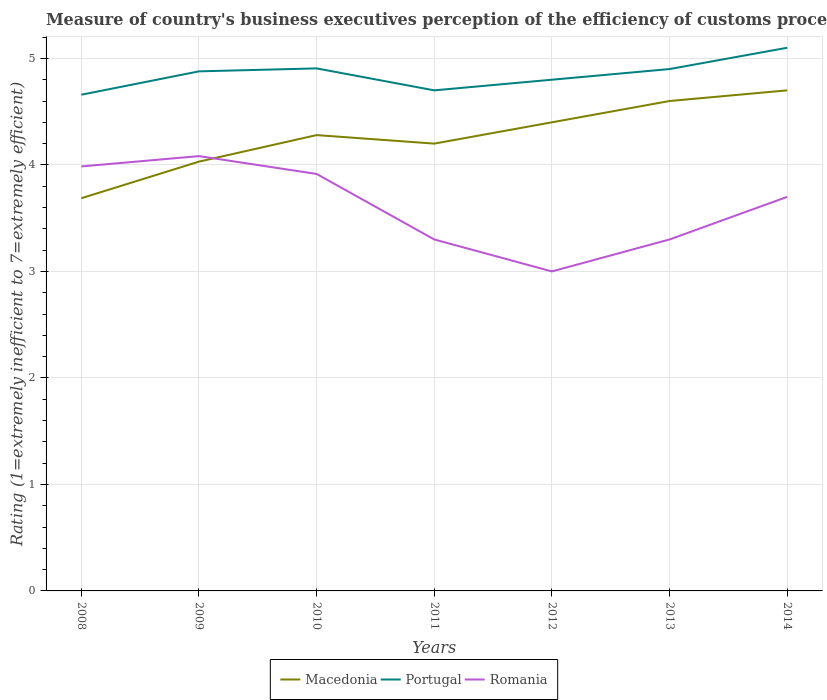Does the line corresponding to Romania intersect with the line corresponding to Portugal?
Provide a succinct answer. No. Across all years, what is the maximum rating of the efficiency of customs procedure in Romania?
Make the answer very short. 3. In which year was the rating of the efficiency of customs procedure in Portugal maximum?
Provide a succinct answer. 2008. What is the total rating of the efficiency of customs procedure in Macedonia in the graph?
Offer a very short reply. -0.4. What is the difference between the highest and the second highest rating of the efficiency of customs procedure in Portugal?
Keep it short and to the point. 0.44. What is the difference between the highest and the lowest rating of the efficiency of customs procedure in Macedonia?
Keep it short and to the point. 4. Is the rating of the efficiency of customs procedure in Romania strictly greater than the rating of the efficiency of customs procedure in Macedonia over the years?
Give a very brief answer. No. How many years are there in the graph?
Make the answer very short. 7. What is the difference between two consecutive major ticks on the Y-axis?
Make the answer very short. 1. Does the graph contain grids?
Your response must be concise. Yes. Where does the legend appear in the graph?
Provide a short and direct response. Bottom center. How many legend labels are there?
Provide a succinct answer. 3. How are the legend labels stacked?
Offer a very short reply. Horizontal. What is the title of the graph?
Offer a very short reply. Measure of country's business executives perception of the efficiency of customs procedures. What is the label or title of the X-axis?
Your response must be concise. Years. What is the label or title of the Y-axis?
Your answer should be very brief. Rating (1=extremely inefficient to 7=extremely efficient). What is the Rating (1=extremely inefficient to 7=extremely efficient) of Macedonia in 2008?
Your answer should be very brief. 3.69. What is the Rating (1=extremely inefficient to 7=extremely efficient) of Portugal in 2008?
Ensure brevity in your answer.  4.66. What is the Rating (1=extremely inefficient to 7=extremely efficient) in Romania in 2008?
Provide a short and direct response. 3.99. What is the Rating (1=extremely inefficient to 7=extremely efficient) of Macedonia in 2009?
Provide a short and direct response. 4.03. What is the Rating (1=extremely inefficient to 7=extremely efficient) in Portugal in 2009?
Offer a very short reply. 4.88. What is the Rating (1=extremely inefficient to 7=extremely efficient) in Romania in 2009?
Offer a terse response. 4.08. What is the Rating (1=extremely inefficient to 7=extremely efficient) of Macedonia in 2010?
Offer a terse response. 4.28. What is the Rating (1=extremely inefficient to 7=extremely efficient) in Portugal in 2010?
Give a very brief answer. 4.91. What is the Rating (1=extremely inefficient to 7=extremely efficient) of Romania in 2010?
Your response must be concise. 3.92. What is the Rating (1=extremely inefficient to 7=extremely efficient) in Macedonia in 2011?
Offer a terse response. 4.2. What is the Rating (1=extremely inefficient to 7=extremely efficient) of Portugal in 2011?
Provide a short and direct response. 4.7. What is the Rating (1=extremely inefficient to 7=extremely efficient) in Romania in 2011?
Offer a very short reply. 3.3. What is the Rating (1=extremely inefficient to 7=extremely efficient) of Macedonia in 2012?
Your response must be concise. 4.4. What is the Rating (1=extremely inefficient to 7=extremely efficient) in Portugal in 2012?
Make the answer very short. 4.8. What is the Rating (1=extremely inefficient to 7=extremely efficient) in Macedonia in 2013?
Provide a succinct answer. 4.6. What is the Rating (1=extremely inefficient to 7=extremely efficient) of Romania in 2013?
Provide a short and direct response. 3.3. What is the Rating (1=extremely inefficient to 7=extremely efficient) of Macedonia in 2014?
Give a very brief answer. 4.7. What is the Rating (1=extremely inefficient to 7=extremely efficient) of Romania in 2014?
Your answer should be compact. 3.7. Across all years, what is the maximum Rating (1=extremely inefficient to 7=extremely efficient) of Romania?
Give a very brief answer. 4.08. Across all years, what is the minimum Rating (1=extremely inefficient to 7=extremely efficient) of Macedonia?
Give a very brief answer. 3.69. Across all years, what is the minimum Rating (1=extremely inefficient to 7=extremely efficient) in Portugal?
Ensure brevity in your answer.  4.66. Across all years, what is the minimum Rating (1=extremely inefficient to 7=extremely efficient) of Romania?
Ensure brevity in your answer.  3. What is the total Rating (1=extremely inefficient to 7=extremely efficient) in Macedonia in the graph?
Your answer should be very brief. 29.9. What is the total Rating (1=extremely inefficient to 7=extremely efficient) in Portugal in the graph?
Your answer should be compact. 33.94. What is the total Rating (1=extremely inefficient to 7=extremely efficient) of Romania in the graph?
Give a very brief answer. 25.28. What is the difference between the Rating (1=extremely inefficient to 7=extremely efficient) in Macedonia in 2008 and that in 2009?
Your answer should be compact. -0.34. What is the difference between the Rating (1=extremely inefficient to 7=extremely efficient) of Portugal in 2008 and that in 2009?
Offer a terse response. -0.22. What is the difference between the Rating (1=extremely inefficient to 7=extremely efficient) in Romania in 2008 and that in 2009?
Ensure brevity in your answer.  -0.1. What is the difference between the Rating (1=extremely inefficient to 7=extremely efficient) of Macedonia in 2008 and that in 2010?
Your response must be concise. -0.59. What is the difference between the Rating (1=extremely inefficient to 7=extremely efficient) in Portugal in 2008 and that in 2010?
Give a very brief answer. -0.25. What is the difference between the Rating (1=extremely inefficient to 7=extremely efficient) of Romania in 2008 and that in 2010?
Provide a short and direct response. 0.07. What is the difference between the Rating (1=extremely inefficient to 7=extremely efficient) of Macedonia in 2008 and that in 2011?
Keep it short and to the point. -0.51. What is the difference between the Rating (1=extremely inefficient to 7=extremely efficient) in Portugal in 2008 and that in 2011?
Ensure brevity in your answer.  -0.04. What is the difference between the Rating (1=extremely inefficient to 7=extremely efficient) of Romania in 2008 and that in 2011?
Ensure brevity in your answer.  0.69. What is the difference between the Rating (1=extremely inefficient to 7=extremely efficient) in Macedonia in 2008 and that in 2012?
Ensure brevity in your answer.  -0.71. What is the difference between the Rating (1=extremely inefficient to 7=extremely efficient) of Portugal in 2008 and that in 2012?
Offer a terse response. -0.14. What is the difference between the Rating (1=extremely inefficient to 7=extremely efficient) in Romania in 2008 and that in 2012?
Offer a very short reply. 0.99. What is the difference between the Rating (1=extremely inefficient to 7=extremely efficient) of Macedonia in 2008 and that in 2013?
Your answer should be compact. -0.91. What is the difference between the Rating (1=extremely inefficient to 7=extremely efficient) of Portugal in 2008 and that in 2013?
Your response must be concise. -0.24. What is the difference between the Rating (1=extremely inefficient to 7=extremely efficient) of Romania in 2008 and that in 2013?
Keep it short and to the point. 0.69. What is the difference between the Rating (1=extremely inefficient to 7=extremely efficient) of Macedonia in 2008 and that in 2014?
Keep it short and to the point. -1.01. What is the difference between the Rating (1=extremely inefficient to 7=extremely efficient) in Portugal in 2008 and that in 2014?
Offer a very short reply. -0.44. What is the difference between the Rating (1=extremely inefficient to 7=extremely efficient) of Romania in 2008 and that in 2014?
Provide a short and direct response. 0.29. What is the difference between the Rating (1=extremely inefficient to 7=extremely efficient) in Macedonia in 2009 and that in 2010?
Offer a terse response. -0.25. What is the difference between the Rating (1=extremely inefficient to 7=extremely efficient) in Portugal in 2009 and that in 2010?
Make the answer very short. -0.03. What is the difference between the Rating (1=extremely inefficient to 7=extremely efficient) of Romania in 2009 and that in 2010?
Your answer should be very brief. 0.17. What is the difference between the Rating (1=extremely inefficient to 7=extremely efficient) in Macedonia in 2009 and that in 2011?
Your answer should be very brief. -0.17. What is the difference between the Rating (1=extremely inefficient to 7=extremely efficient) of Portugal in 2009 and that in 2011?
Provide a short and direct response. 0.18. What is the difference between the Rating (1=extremely inefficient to 7=extremely efficient) of Romania in 2009 and that in 2011?
Your answer should be very brief. 0.78. What is the difference between the Rating (1=extremely inefficient to 7=extremely efficient) in Macedonia in 2009 and that in 2012?
Make the answer very short. -0.37. What is the difference between the Rating (1=extremely inefficient to 7=extremely efficient) in Portugal in 2009 and that in 2012?
Ensure brevity in your answer.  0.08. What is the difference between the Rating (1=extremely inefficient to 7=extremely efficient) in Romania in 2009 and that in 2012?
Make the answer very short. 1.08. What is the difference between the Rating (1=extremely inefficient to 7=extremely efficient) in Macedonia in 2009 and that in 2013?
Offer a very short reply. -0.57. What is the difference between the Rating (1=extremely inefficient to 7=extremely efficient) in Portugal in 2009 and that in 2013?
Make the answer very short. -0.02. What is the difference between the Rating (1=extremely inefficient to 7=extremely efficient) of Romania in 2009 and that in 2013?
Your answer should be compact. 0.78. What is the difference between the Rating (1=extremely inefficient to 7=extremely efficient) in Macedonia in 2009 and that in 2014?
Give a very brief answer. -0.67. What is the difference between the Rating (1=extremely inefficient to 7=extremely efficient) in Portugal in 2009 and that in 2014?
Keep it short and to the point. -0.22. What is the difference between the Rating (1=extremely inefficient to 7=extremely efficient) of Romania in 2009 and that in 2014?
Your answer should be very brief. 0.38. What is the difference between the Rating (1=extremely inefficient to 7=extremely efficient) in Portugal in 2010 and that in 2011?
Provide a short and direct response. 0.21. What is the difference between the Rating (1=extremely inefficient to 7=extremely efficient) in Romania in 2010 and that in 2011?
Provide a succinct answer. 0.62. What is the difference between the Rating (1=extremely inefficient to 7=extremely efficient) in Macedonia in 2010 and that in 2012?
Your answer should be very brief. -0.12. What is the difference between the Rating (1=extremely inefficient to 7=extremely efficient) in Portugal in 2010 and that in 2012?
Your answer should be compact. 0.11. What is the difference between the Rating (1=extremely inefficient to 7=extremely efficient) of Romania in 2010 and that in 2012?
Give a very brief answer. 0.92. What is the difference between the Rating (1=extremely inefficient to 7=extremely efficient) of Macedonia in 2010 and that in 2013?
Provide a succinct answer. -0.32. What is the difference between the Rating (1=extremely inefficient to 7=extremely efficient) in Portugal in 2010 and that in 2013?
Make the answer very short. 0.01. What is the difference between the Rating (1=extremely inefficient to 7=extremely efficient) in Romania in 2010 and that in 2013?
Your answer should be very brief. 0.62. What is the difference between the Rating (1=extremely inefficient to 7=extremely efficient) of Macedonia in 2010 and that in 2014?
Give a very brief answer. -0.42. What is the difference between the Rating (1=extremely inefficient to 7=extremely efficient) of Portugal in 2010 and that in 2014?
Offer a very short reply. -0.19. What is the difference between the Rating (1=extremely inefficient to 7=extremely efficient) in Romania in 2010 and that in 2014?
Your answer should be very brief. 0.22. What is the difference between the Rating (1=extremely inefficient to 7=extremely efficient) of Macedonia in 2011 and that in 2012?
Your response must be concise. -0.2. What is the difference between the Rating (1=extremely inefficient to 7=extremely efficient) of Portugal in 2011 and that in 2012?
Your answer should be very brief. -0.1. What is the difference between the Rating (1=extremely inefficient to 7=extremely efficient) of Romania in 2011 and that in 2012?
Offer a very short reply. 0.3. What is the difference between the Rating (1=extremely inefficient to 7=extremely efficient) of Macedonia in 2011 and that in 2013?
Offer a very short reply. -0.4. What is the difference between the Rating (1=extremely inefficient to 7=extremely efficient) in Portugal in 2011 and that in 2014?
Provide a succinct answer. -0.4. What is the difference between the Rating (1=extremely inefficient to 7=extremely efficient) of Romania in 2011 and that in 2014?
Ensure brevity in your answer.  -0.4. What is the difference between the Rating (1=extremely inefficient to 7=extremely efficient) in Portugal in 2012 and that in 2013?
Provide a succinct answer. -0.1. What is the difference between the Rating (1=extremely inefficient to 7=extremely efficient) of Portugal in 2012 and that in 2014?
Offer a terse response. -0.3. What is the difference between the Rating (1=extremely inefficient to 7=extremely efficient) in Romania in 2012 and that in 2014?
Offer a very short reply. -0.7. What is the difference between the Rating (1=extremely inefficient to 7=extremely efficient) of Portugal in 2013 and that in 2014?
Give a very brief answer. -0.2. What is the difference between the Rating (1=extremely inefficient to 7=extremely efficient) in Macedonia in 2008 and the Rating (1=extremely inefficient to 7=extremely efficient) in Portugal in 2009?
Ensure brevity in your answer.  -1.19. What is the difference between the Rating (1=extremely inefficient to 7=extremely efficient) of Macedonia in 2008 and the Rating (1=extremely inefficient to 7=extremely efficient) of Romania in 2009?
Provide a succinct answer. -0.4. What is the difference between the Rating (1=extremely inefficient to 7=extremely efficient) in Portugal in 2008 and the Rating (1=extremely inefficient to 7=extremely efficient) in Romania in 2009?
Give a very brief answer. 0.58. What is the difference between the Rating (1=extremely inefficient to 7=extremely efficient) of Macedonia in 2008 and the Rating (1=extremely inefficient to 7=extremely efficient) of Portugal in 2010?
Provide a succinct answer. -1.22. What is the difference between the Rating (1=extremely inefficient to 7=extremely efficient) of Macedonia in 2008 and the Rating (1=extremely inefficient to 7=extremely efficient) of Romania in 2010?
Your answer should be compact. -0.23. What is the difference between the Rating (1=extremely inefficient to 7=extremely efficient) in Portugal in 2008 and the Rating (1=extremely inefficient to 7=extremely efficient) in Romania in 2010?
Ensure brevity in your answer.  0.74. What is the difference between the Rating (1=extremely inefficient to 7=extremely efficient) of Macedonia in 2008 and the Rating (1=extremely inefficient to 7=extremely efficient) of Portugal in 2011?
Make the answer very short. -1.01. What is the difference between the Rating (1=extremely inefficient to 7=extremely efficient) in Macedonia in 2008 and the Rating (1=extremely inefficient to 7=extremely efficient) in Romania in 2011?
Provide a short and direct response. 0.39. What is the difference between the Rating (1=extremely inefficient to 7=extremely efficient) of Portugal in 2008 and the Rating (1=extremely inefficient to 7=extremely efficient) of Romania in 2011?
Make the answer very short. 1.36. What is the difference between the Rating (1=extremely inefficient to 7=extremely efficient) in Macedonia in 2008 and the Rating (1=extremely inefficient to 7=extremely efficient) in Portugal in 2012?
Ensure brevity in your answer.  -1.11. What is the difference between the Rating (1=extremely inefficient to 7=extremely efficient) in Macedonia in 2008 and the Rating (1=extremely inefficient to 7=extremely efficient) in Romania in 2012?
Your answer should be very brief. 0.69. What is the difference between the Rating (1=extremely inefficient to 7=extremely efficient) of Portugal in 2008 and the Rating (1=extremely inefficient to 7=extremely efficient) of Romania in 2012?
Your answer should be very brief. 1.66. What is the difference between the Rating (1=extremely inefficient to 7=extremely efficient) of Macedonia in 2008 and the Rating (1=extremely inefficient to 7=extremely efficient) of Portugal in 2013?
Offer a very short reply. -1.21. What is the difference between the Rating (1=extremely inefficient to 7=extremely efficient) in Macedonia in 2008 and the Rating (1=extremely inefficient to 7=extremely efficient) in Romania in 2013?
Provide a succinct answer. 0.39. What is the difference between the Rating (1=extremely inefficient to 7=extremely efficient) in Portugal in 2008 and the Rating (1=extremely inefficient to 7=extremely efficient) in Romania in 2013?
Make the answer very short. 1.36. What is the difference between the Rating (1=extremely inefficient to 7=extremely efficient) of Macedonia in 2008 and the Rating (1=extremely inefficient to 7=extremely efficient) of Portugal in 2014?
Give a very brief answer. -1.41. What is the difference between the Rating (1=extremely inefficient to 7=extremely efficient) of Macedonia in 2008 and the Rating (1=extremely inefficient to 7=extremely efficient) of Romania in 2014?
Provide a short and direct response. -0.01. What is the difference between the Rating (1=extremely inefficient to 7=extremely efficient) in Macedonia in 2009 and the Rating (1=extremely inefficient to 7=extremely efficient) in Portugal in 2010?
Your response must be concise. -0.88. What is the difference between the Rating (1=extremely inefficient to 7=extremely efficient) of Macedonia in 2009 and the Rating (1=extremely inefficient to 7=extremely efficient) of Romania in 2010?
Your answer should be very brief. 0.12. What is the difference between the Rating (1=extremely inefficient to 7=extremely efficient) in Portugal in 2009 and the Rating (1=extremely inefficient to 7=extremely efficient) in Romania in 2010?
Your answer should be very brief. 0.96. What is the difference between the Rating (1=extremely inefficient to 7=extremely efficient) in Macedonia in 2009 and the Rating (1=extremely inefficient to 7=extremely efficient) in Portugal in 2011?
Your answer should be compact. -0.67. What is the difference between the Rating (1=extremely inefficient to 7=extremely efficient) of Macedonia in 2009 and the Rating (1=extremely inefficient to 7=extremely efficient) of Romania in 2011?
Offer a terse response. 0.73. What is the difference between the Rating (1=extremely inefficient to 7=extremely efficient) of Portugal in 2009 and the Rating (1=extremely inefficient to 7=extremely efficient) of Romania in 2011?
Offer a terse response. 1.58. What is the difference between the Rating (1=extremely inefficient to 7=extremely efficient) of Macedonia in 2009 and the Rating (1=extremely inefficient to 7=extremely efficient) of Portugal in 2012?
Offer a very short reply. -0.77. What is the difference between the Rating (1=extremely inefficient to 7=extremely efficient) in Macedonia in 2009 and the Rating (1=extremely inefficient to 7=extremely efficient) in Romania in 2012?
Provide a short and direct response. 1.03. What is the difference between the Rating (1=extremely inefficient to 7=extremely efficient) in Portugal in 2009 and the Rating (1=extremely inefficient to 7=extremely efficient) in Romania in 2012?
Provide a short and direct response. 1.88. What is the difference between the Rating (1=extremely inefficient to 7=extremely efficient) of Macedonia in 2009 and the Rating (1=extremely inefficient to 7=extremely efficient) of Portugal in 2013?
Your answer should be compact. -0.87. What is the difference between the Rating (1=extremely inefficient to 7=extremely efficient) of Macedonia in 2009 and the Rating (1=extremely inefficient to 7=extremely efficient) of Romania in 2013?
Your answer should be very brief. 0.73. What is the difference between the Rating (1=extremely inefficient to 7=extremely efficient) in Portugal in 2009 and the Rating (1=extremely inefficient to 7=extremely efficient) in Romania in 2013?
Give a very brief answer. 1.58. What is the difference between the Rating (1=extremely inefficient to 7=extremely efficient) of Macedonia in 2009 and the Rating (1=extremely inefficient to 7=extremely efficient) of Portugal in 2014?
Ensure brevity in your answer.  -1.07. What is the difference between the Rating (1=extremely inefficient to 7=extremely efficient) of Macedonia in 2009 and the Rating (1=extremely inefficient to 7=extremely efficient) of Romania in 2014?
Give a very brief answer. 0.33. What is the difference between the Rating (1=extremely inefficient to 7=extremely efficient) of Portugal in 2009 and the Rating (1=extremely inefficient to 7=extremely efficient) of Romania in 2014?
Ensure brevity in your answer.  1.18. What is the difference between the Rating (1=extremely inefficient to 7=extremely efficient) of Macedonia in 2010 and the Rating (1=extremely inefficient to 7=extremely efficient) of Portugal in 2011?
Provide a succinct answer. -0.42. What is the difference between the Rating (1=extremely inefficient to 7=extremely efficient) of Portugal in 2010 and the Rating (1=extremely inefficient to 7=extremely efficient) of Romania in 2011?
Provide a short and direct response. 1.61. What is the difference between the Rating (1=extremely inefficient to 7=extremely efficient) of Macedonia in 2010 and the Rating (1=extremely inefficient to 7=extremely efficient) of Portugal in 2012?
Offer a very short reply. -0.52. What is the difference between the Rating (1=extremely inefficient to 7=extremely efficient) in Macedonia in 2010 and the Rating (1=extremely inefficient to 7=extremely efficient) in Romania in 2012?
Keep it short and to the point. 1.28. What is the difference between the Rating (1=extremely inefficient to 7=extremely efficient) of Portugal in 2010 and the Rating (1=extremely inefficient to 7=extremely efficient) of Romania in 2012?
Give a very brief answer. 1.91. What is the difference between the Rating (1=extremely inefficient to 7=extremely efficient) in Macedonia in 2010 and the Rating (1=extremely inefficient to 7=extremely efficient) in Portugal in 2013?
Make the answer very short. -0.62. What is the difference between the Rating (1=extremely inefficient to 7=extremely efficient) of Portugal in 2010 and the Rating (1=extremely inefficient to 7=extremely efficient) of Romania in 2013?
Your answer should be very brief. 1.61. What is the difference between the Rating (1=extremely inefficient to 7=extremely efficient) in Macedonia in 2010 and the Rating (1=extremely inefficient to 7=extremely efficient) in Portugal in 2014?
Provide a succinct answer. -0.82. What is the difference between the Rating (1=extremely inefficient to 7=extremely efficient) of Macedonia in 2010 and the Rating (1=extremely inefficient to 7=extremely efficient) of Romania in 2014?
Your response must be concise. 0.58. What is the difference between the Rating (1=extremely inefficient to 7=extremely efficient) of Portugal in 2010 and the Rating (1=extremely inefficient to 7=extremely efficient) of Romania in 2014?
Ensure brevity in your answer.  1.21. What is the difference between the Rating (1=extremely inefficient to 7=extremely efficient) in Macedonia in 2012 and the Rating (1=extremely inefficient to 7=extremely efficient) in Portugal in 2013?
Provide a short and direct response. -0.5. What is the difference between the Rating (1=extremely inefficient to 7=extremely efficient) of Macedonia in 2012 and the Rating (1=extremely inefficient to 7=extremely efficient) of Romania in 2013?
Your answer should be compact. 1.1. What is the difference between the Rating (1=extremely inefficient to 7=extremely efficient) in Portugal in 2012 and the Rating (1=extremely inefficient to 7=extremely efficient) in Romania in 2013?
Your answer should be compact. 1.5. What is the difference between the Rating (1=extremely inefficient to 7=extremely efficient) of Macedonia in 2012 and the Rating (1=extremely inefficient to 7=extremely efficient) of Portugal in 2014?
Your answer should be very brief. -0.7. What is the difference between the Rating (1=extremely inefficient to 7=extremely efficient) in Portugal in 2013 and the Rating (1=extremely inefficient to 7=extremely efficient) in Romania in 2014?
Make the answer very short. 1.2. What is the average Rating (1=extremely inefficient to 7=extremely efficient) in Macedonia per year?
Your answer should be compact. 4.27. What is the average Rating (1=extremely inefficient to 7=extremely efficient) of Portugal per year?
Your response must be concise. 4.85. What is the average Rating (1=extremely inefficient to 7=extremely efficient) in Romania per year?
Your answer should be compact. 3.61. In the year 2008, what is the difference between the Rating (1=extremely inefficient to 7=extremely efficient) in Macedonia and Rating (1=extremely inefficient to 7=extremely efficient) in Portugal?
Provide a short and direct response. -0.97. In the year 2008, what is the difference between the Rating (1=extremely inefficient to 7=extremely efficient) in Macedonia and Rating (1=extremely inefficient to 7=extremely efficient) in Romania?
Keep it short and to the point. -0.3. In the year 2008, what is the difference between the Rating (1=extremely inefficient to 7=extremely efficient) of Portugal and Rating (1=extremely inefficient to 7=extremely efficient) of Romania?
Keep it short and to the point. 0.67. In the year 2009, what is the difference between the Rating (1=extremely inefficient to 7=extremely efficient) of Macedonia and Rating (1=extremely inefficient to 7=extremely efficient) of Portugal?
Your answer should be very brief. -0.85. In the year 2009, what is the difference between the Rating (1=extremely inefficient to 7=extremely efficient) in Macedonia and Rating (1=extremely inefficient to 7=extremely efficient) in Romania?
Give a very brief answer. -0.05. In the year 2009, what is the difference between the Rating (1=extremely inefficient to 7=extremely efficient) in Portugal and Rating (1=extremely inefficient to 7=extremely efficient) in Romania?
Your answer should be compact. 0.8. In the year 2010, what is the difference between the Rating (1=extremely inefficient to 7=extremely efficient) of Macedonia and Rating (1=extremely inefficient to 7=extremely efficient) of Portugal?
Keep it short and to the point. -0.63. In the year 2010, what is the difference between the Rating (1=extremely inefficient to 7=extremely efficient) of Macedonia and Rating (1=extremely inefficient to 7=extremely efficient) of Romania?
Offer a terse response. 0.36. In the year 2011, what is the difference between the Rating (1=extremely inefficient to 7=extremely efficient) in Macedonia and Rating (1=extremely inefficient to 7=extremely efficient) in Portugal?
Make the answer very short. -0.5. In the year 2011, what is the difference between the Rating (1=extremely inefficient to 7=extremely efficient) in Macedonia and Rating (1=extremely inefficient to 7=extremely efficient) in Romania?
Ensure brevity in your answer.  0.9. In the year 2011, what is the difference between the Rating (1=extremely inefficient to 7=extremely efficient) in Portugal and Rating (1=extremely inefficient to 7=extremely efficient) in Romania?
Keep it short and to the point. 1.4. In the year 2012, what is the difference between the Rating (1=extremely inefficient to 7=extremely efficient) in Macedonia and Rating (1=extremely inefficient to 7=extremely efficient) in Portugal?
Offer a terse response. -0.4. In the year 2012, what is the difference between the Rating (1=extremely inefficient to 7=extremely efficient) of Portugal and Rating (1=extremely inefficient to 7=extremely efficient) of Romania?
Your answer should be very brief. 1.8. In the year 2013, what is the difference between the Rating (1=extremely inefficient to 7=extremely efficient) of Macedonia and Rating (1=extremely inefficient to 7=extremely efficient) of Portugal?
Provide a succinct answer. -0.3. In the year 2014, what is the difference between the Rating (1=extremely inefficient to 7=extremely efficient) in Macedonia and Rating (1=extremely inefficient to 7=extremely efficient) in Portugal?
Provide a succinct answer. -0.4. In the year 2014, what is the difference between the Rating (1=extremely inefficient to 7=extremely efficient) of Macedonia and Rating (1=extremely inefficient to 7=extremely efficient) of Romania?
Give a very brief answer. 1. What is the ratio of the Rating (1=extremely inefficient to 7=extremely efficient) of Macedonia in 2008 to that in 2009?
Keep it short and to the point. 0.91. What is the ratio of the Rating (1=extremely inefficient to 7=extremely efficient) in Portugal in 2008 to that in 2009?
Offer a terse response. 0.95. What is the ratio of the Rating (1=extremely inefficient to 7=extremely efficient) in Romania in 2008 to that in 2009?
Your response must be concise. 0.98. What is the ratio of the Rating (1=extremely inefficient to 7=extremely efficient) in Macedonia in 2008 to that in 2010?
Provide a short and direct response. 0.86. What is the ratio of the Rating (1=extremely inefficient to 7=extremely efficient) in Portugal in 2008 to that in 2010?
Your answer should be very brief. 0.95. What is the ratio of the Rating (1=extremely inefficient to 7=extremely efficient) in Macedonia in 2008 to that in 2011?
Make the answer very short. 0.88. What is the ratio of the Rating (1=extremely inefficient to 7=extremely efficient) of Portugal in 2008 to that in 2011?
Offer a terse response. 0.99. What is the ratio of the Rating (1=extremely inefficient to 7=extremely efficient) in Romania in 2008 to that in 2011?
Provide a succinct answer. 1.21. What is the ratio of the Rating (1=extremely inefficient to 7=extremely efficient) in Macedonia in 2008 to that in 2012?
Your response must be concise. 0.84. What is the ratio of the Rating (1=extremely inefficient to 7=extremely efficient) of Portugal in 2008 to that in 2012?
Provide a short and direct response. 0.97. What is the ratio of the Rating (1=extremely inefficient to 7=extremely efficient) in Romania in 2008 to that in 2012?
Your answer should be compact. 1.33. What is the ratio of the Rating (1=extremely inefficient to 7=extremely efficient) in Macedonia in 2008 to that in 2013?
Keep it short and to the point. 0.8. What is the ratio of the Rating (1=extremely inefficient to 7=extremely efficient) in Portugal in 2008 to that in 2013?
Make the answer very short. 0.95. What is the ratio of the Rating (1=extremely inefficient to 7=extremely efficient) in Romania in 2008 to that in 2013?
Offer a very short reply. 1.21. What is the ratio of the Rating (1=extremely inefficient to 7=extremely efficient) of Macedonia in 2008 to that in 2014?
Your response must be concise. 0.78. What is the ratio of the Rating (1=extremely inefficient to 7=extremely efficient) in Portugal in 2008 to that in 2014?
Make the answer very short. 0.91. What is the ratio of the Rating (1=extremely inefficient to 7=extremely efficient) in Romania in 2008 to that in 2014?
Provide a short and direct response. 1.08. What is the ratio of the Rating (1=extremely inefficient to 7=extremely efficient) in Macedonia in 2009 to that in 2010?
Provide a succinct answer. 0.94. What is the ratio of the Rating (1=extremely inefficient to 7=extremely efficient) of Romania in 2009 to that in 2010?
Offer a very short reply. 1.04. What is the ratio of the Rating (1=extremely inefficient to 7=extremely efficient) of Macedonia in 2009 to that in 2011?
Keep it short and to the point. 0.96. What is the ratio of the Rating (1=extremely inefficient to 7=extremely efficient) in Portugal in 2009 to that in 2011?
Offer a terse response. 1.04. What is the ratio of the Rating (1=extremely inefficient to 7=extremely efficient) in Romania in 2009 to that in 2011?
Make the answer very short. 1.24. What is the ratio of the Rating (1=extremely inefficient to 7=extremely efficient) in Macedonia in 2009 to that in 2012?
Your answer should be compact. 0.92. What is the ratio of the Rating (1=extremely inefficient to 7=extremely efficient) of Portugal in 2009 to that in 2012?
Your answer should be very brief. 1.02. What is the ratio of the Rating (1=extremely inefficient to 7=extremely efficient) in Romania in 2009 to that in 2012?
Offer a very short reply. 1.36. What is the ratio of the Rating (1=extremely inefficient to 7=extremely efficient) in Macedonia in 2009 to that in 2013?
Offer a terse response. 0.88. What is the ratio of the Rating (1=extremely inefficient to 7=extremely efficient) in Portugal in 2009 to that in 2013?
Offer a very short reply. 1. What is the ratio of the Rating (1=extremely inefficient to 7=extremely efficient) in Romania in 2009 to that in 2013?
Your response must be concise. 1.24. What is the ratio of the Rating (1=extremely inefficient to 7=extremely efficient) in Macedonia in 2009 to that in 2014?
Give a very brief answer. 0.86. What is the ratio of the Rating (1=extremely inefficient to 7=extremely efficient) of Portugal in 2009 to that in 2014?
Offer a very short reply. 0.96. What is the ratio of the Rating (1=extremely inefficient to 7=extremely efficient) of Romania in 2009 to that in 2014?
Offer a very short reply. 1.1. What is the ratio of the Rating (1=extremely inefficient to 7=extremely efficient) in Macedonia in 2010 to that in 2011?
Your answer should be compact. 1.02. What is the ratio of the Rating (1=extremely inefficient to 7=extremely efficient) of Portugal in 2010 to that in 2011?
Make the answer very short. 1.04. What is the ratio of the Rating (1=extremely inefficient to 7=extremely efficient) in Romania in 2010 to that in 2011?
Make the answer very short. 1.19. What is the ratio of the Rating (1=extremely inefficient to 7=extremely efficient) of Macedonia in 2010 to that in 2012?
Provide a succinct answer. 0.97. What is the ratio of the Rating (1=extremely inefficient to 7=extremely efficient) of Portugal in 2010 to that in 2012?
Your answer should be compact. 1.02. What is the ratio of the Rating (1=extremely inefficient to 7=extremely efficient) in Romania in 2010 to that in 2012?
Provide a short and direct response. 1.31. What is the ratio of the Rating (1=extremely inefficient to 7=extremely efficient) in Macedonia in 2010 to that in 2013?
Your answer should be very brief. 0.93. What is the ratio of the Rating (1=extremely inefficient to 7=extremely efficient) in Romania in 2010 to that in 2013?
Keep it short and to the point. 1.19. What is the ratio of the Rating (1=extremely inefficient to 7=extremely efficient) of Macedonia in 2010 to that in 2014?
Make the answer very short. 0.91. What is the ratio of the Rating (1=extremely inefficient to 7=extremely efficient) of Portugal in 2010 to that in 2014?
Offer a very short reply. 0.96. What is the ratio of the Rating (1=extremely inefficient to 7=extremely efficient) in Romania in 2010 to that in 2014?
Offer a terse response. 1.06. What is the ratio of the Rating (1=extremely inefficient to 7=extremely efficient) of Macedonia in 2011 to that in 2012?
Your answer should be very brief. 0.95. What is the ratio of the Rating (1=extremely inefficient to 7=extremely efficient) in Portugal in 2011 to that in 2012?
Your response must be concise. 0.98. What is the ratio of the Rating (1=extremely inefficient to 7=extremely efficient) of Macedonia in 2011 to that in 2013?
Give a very brief answer. 0.91. What is the ratio of the Rating (1=extremely inefficient to 7=extremely efficient) in Portugal in 2011 to that in 2013?
Make the answer very short. 0.96. What is the ratio of the Rating (1=extremely inefficient to 7=extremely efficient) in Macedonia in 2011 to that in 2014?
Your answer should be very brief. 0.89. What is the ratio of the Rating (1=extremely inefficient to 7=extremely efficient) in Portugal in 2011 to that in 2014?
Provide a succinct answer. 0.92. What is the ratio of the Rating (1=extremely inefficient to 7=extremely efficient) of Romania in 2011 to that in 2014?
Keep it short and to the point. 0.89. What is the ratio of the Rating (1=extremely inefficient to 7=extremely efficient) of Macedonia in 2012 to that in 2013?
Offer a terse response. 0.96. What is the ratio of the Rating (1=extremely inefficient to 7=extremely efficient) of Portugal in 2012 to that in 2013?
Provide a short and direct response. 0.98. What is the ratio of the Rating (1=extremely inefficient to 7=extremely efficient) of Macedonia in 2012 to that in 2014?
Offer a terse response. 0.94. What is the ratio of the Rating (1=extremely inefficient to 7=extremely efficient) of Romania in 2012 to that in 2014?
Offer a very short reply. 0.81. What is the ratio of the Rating (1=extremely inefficient to 7=extremely efficient) of Macedonia in 2013 to that in 2014?
Provide a succinct answer. 0.98. What is the ratio of the Rating (1=extremely inefficient to 7=extremely efficient) of Portugal in 2013 to that in 2014?
Provide a short and direct response. 0.96. What is the ratio of the Rating (1=extremely inefficient to 7=extremely efficient) in Romania in 2013 to that in 2014?
Provide a succinct answer. 0.89. What is the difference between the highest and the second highest Rating (1=extremely inefficient to 7=extremely efficient) of Portugal?
Offer a very short reply. 0.19. What is the difference between the highest and the second highest Rating (1=extremely inefficient to 7=extremely efficient) in Romania?
Give a very brief answer. 0.1. What is the difference between the highest and the lowest Rating (1=extremely inefficient to 7=extremely efficient) in Macedonia?
Your answer should be compact. 1.01. What is the difference between the highest and the lowest Rating (1=extremely inefficient to 7=extremely efficient) in Portugal?
Your answer should be compact. 0.44. What is the difference between the highest and the lowest Rating (1=extremely inefficient to 7=extremely efficient) in Romania?
Ensure brevity in your answer.  1.08. 